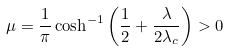Convert formula to latex. <formula><loc_0><loc_0><loc_500><loc_500>\mu = \frac { 1 } { \pi } \cosh ^ { - 1 } \left ( \frac { 1 } { 2 } + \frac { \lambda } { 2 \lambda _ { c } } \right ) > 0</formula> 